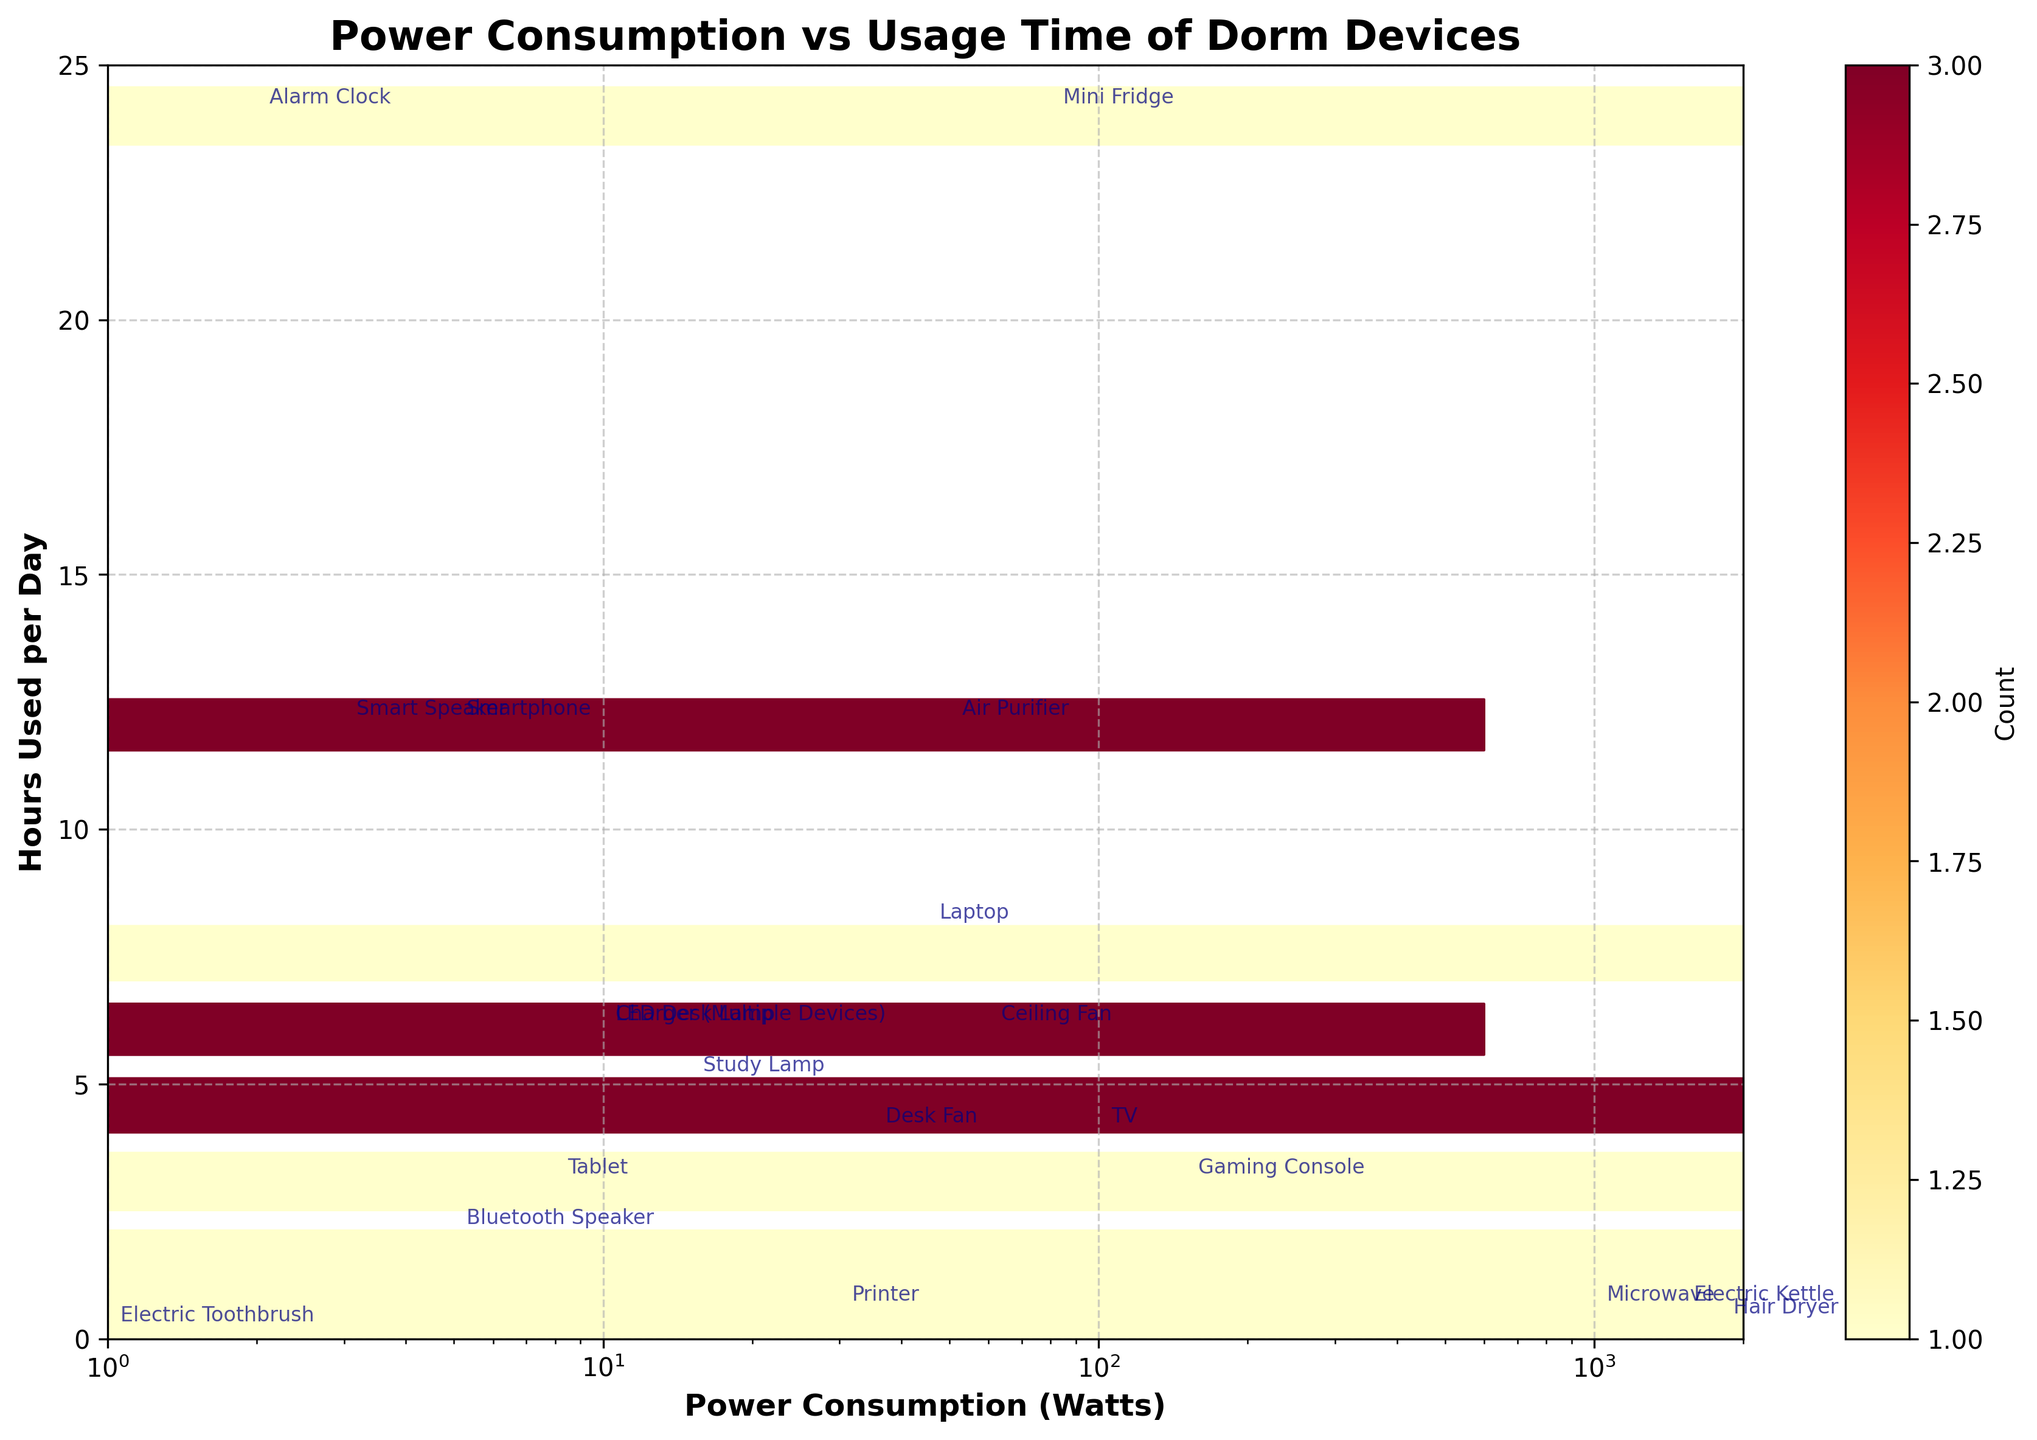What is the title of the plot? The title is located at the top of the figure, providing a brief description of the visualized data.
Answer: Power Consumption vs Usage Time of Dorm Devices What are the units used for the x-axis and y-axis? The x-axis represents Power Consumption in Watts, while the y-axis represents Hours Used per Day, as indicated by the axis labels.
Answer: Watts and Hours Which device has the highest power consumption? By looking for the highest x-value on the plot, you'll find the device annotated near 1800 Watts.
Answer: Hair Dryer How many devices are used for more than 10 hours per day? By counting the annotations on points above the 10-hours line on the y-axis, you can determine the number of such devices.
Answer: 5 Which device has the lowest power consumption, and how many hours is it used per day? By finding the lowest x-value and checking the associated y-value and annotation, the device and its usage can be identified.
Answer: Electric Toothbrush, 0.1 hours Which device is used for the maximum number of hours per day? Look for the point with the highest y-value and identify the annotated device.
Answer: Alarm Clock Compare the power consumption of the Laptop and TV; which one consumes more power? Find the annotated points for both Laptop and TV and compare their x-values.
Answer: TV How many devices have a power consumption between 50 and 100 Watts? Count the annotated points within the x-axis range of 50 to 100 Watts.
Answer: 4 What is the range of power consumption values shown on the x-axis? The x-axis limits provide the range; it starts at 1 Watt and extends to 2000 Watts as shown by the axis scale.
Answer: 1 to 2000 Which device has roughly similar power consumption to the Mini Fridge but is used for fewer hours? Compare the annotated points close to the Mini Fridge's 80 Watts and find one with a lower y-value.
Answer: Ceiling Fan 